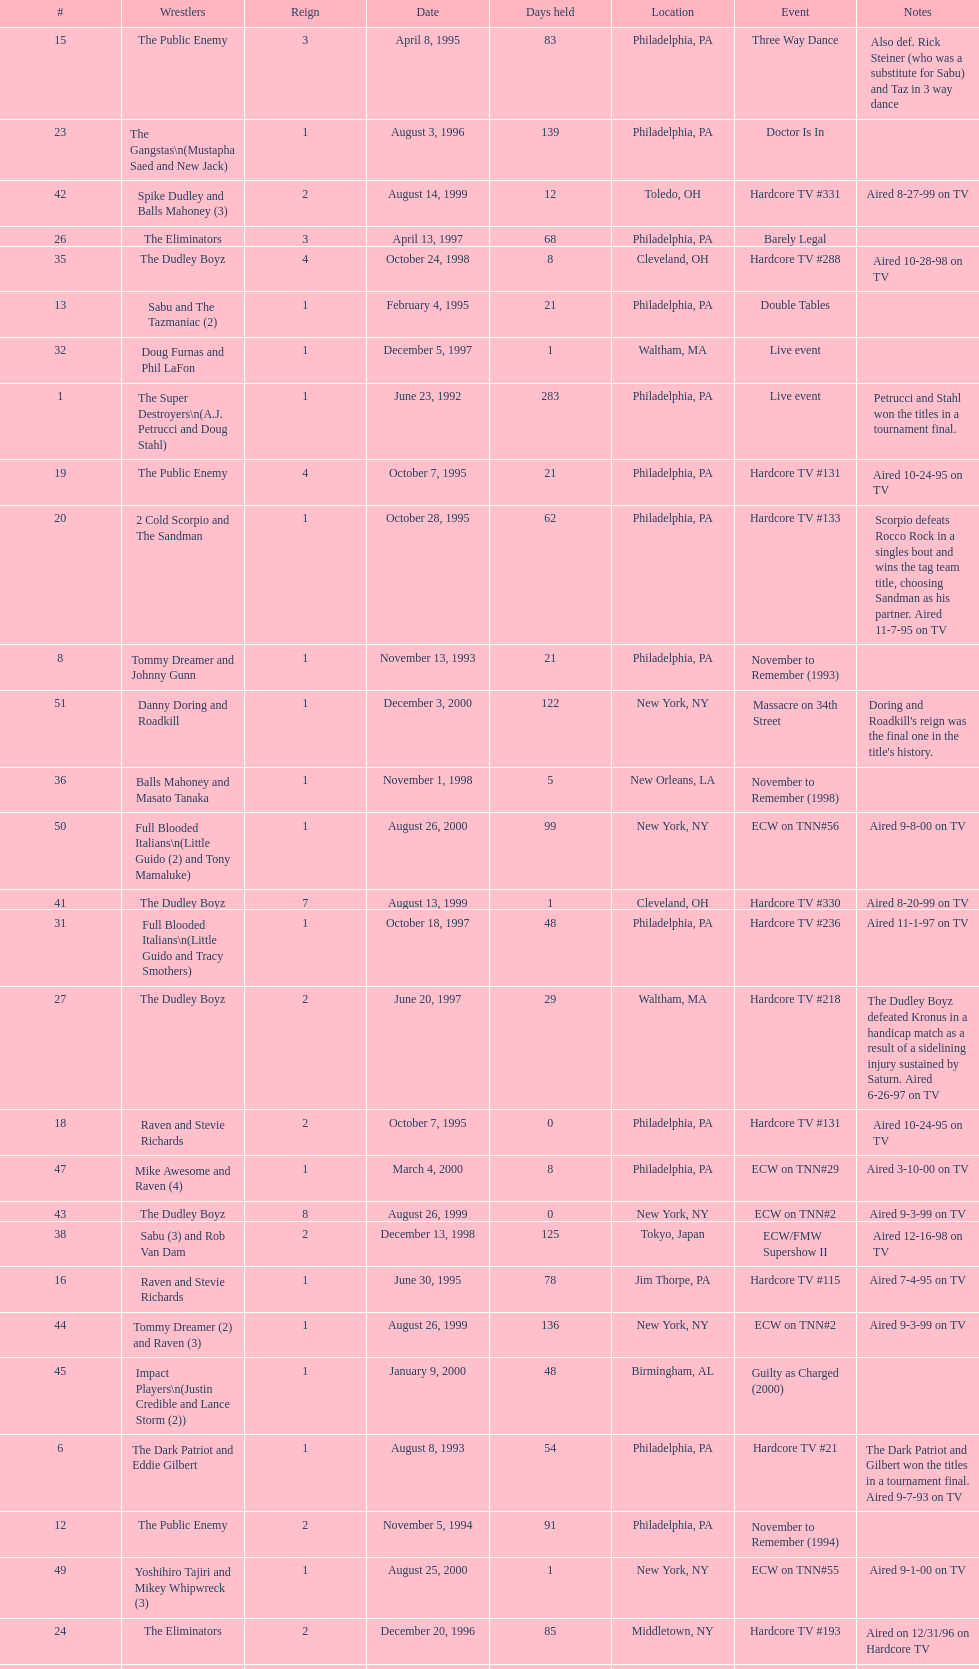Between june 23, 1992 and december 3, 2000, how many instances did the suicide blondes possess the championship? 2. 